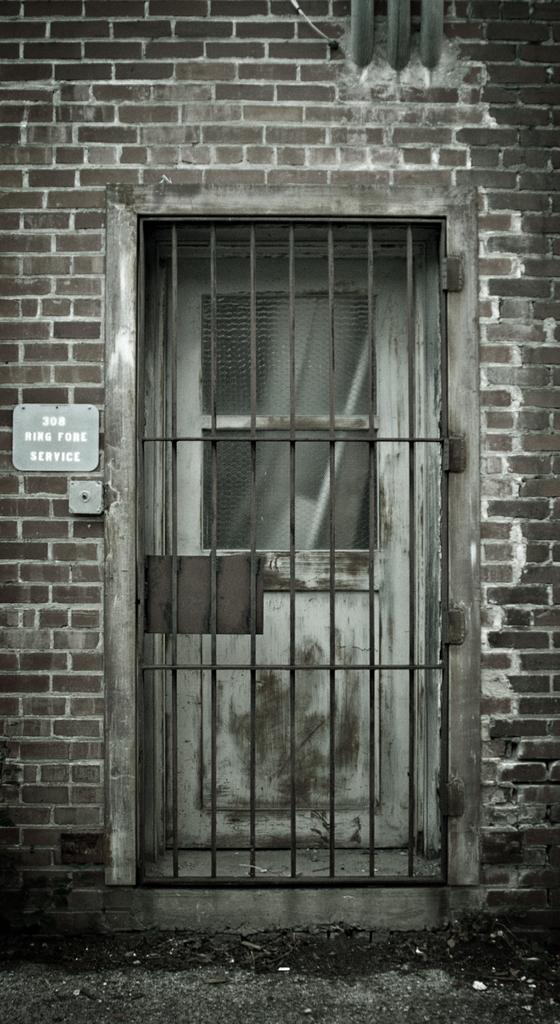What is the main structure in the center of the image? There is a metal gate in the center of the image. What is located behind the metal gate? There is a door behind the gate. What can be seen at the top of the image? There are pipes at the top side of the image. Where is the number plate located in the image? The number plate is on the left side of the image. What type of education is being offered at the store in the image? There is no store or education being offered in the image; it features a metal gate, a door, pipes, and a number plate. Can you see any fangs on the metal gate in the image? There are no fangs present on the metal gate or any other part of the image. 